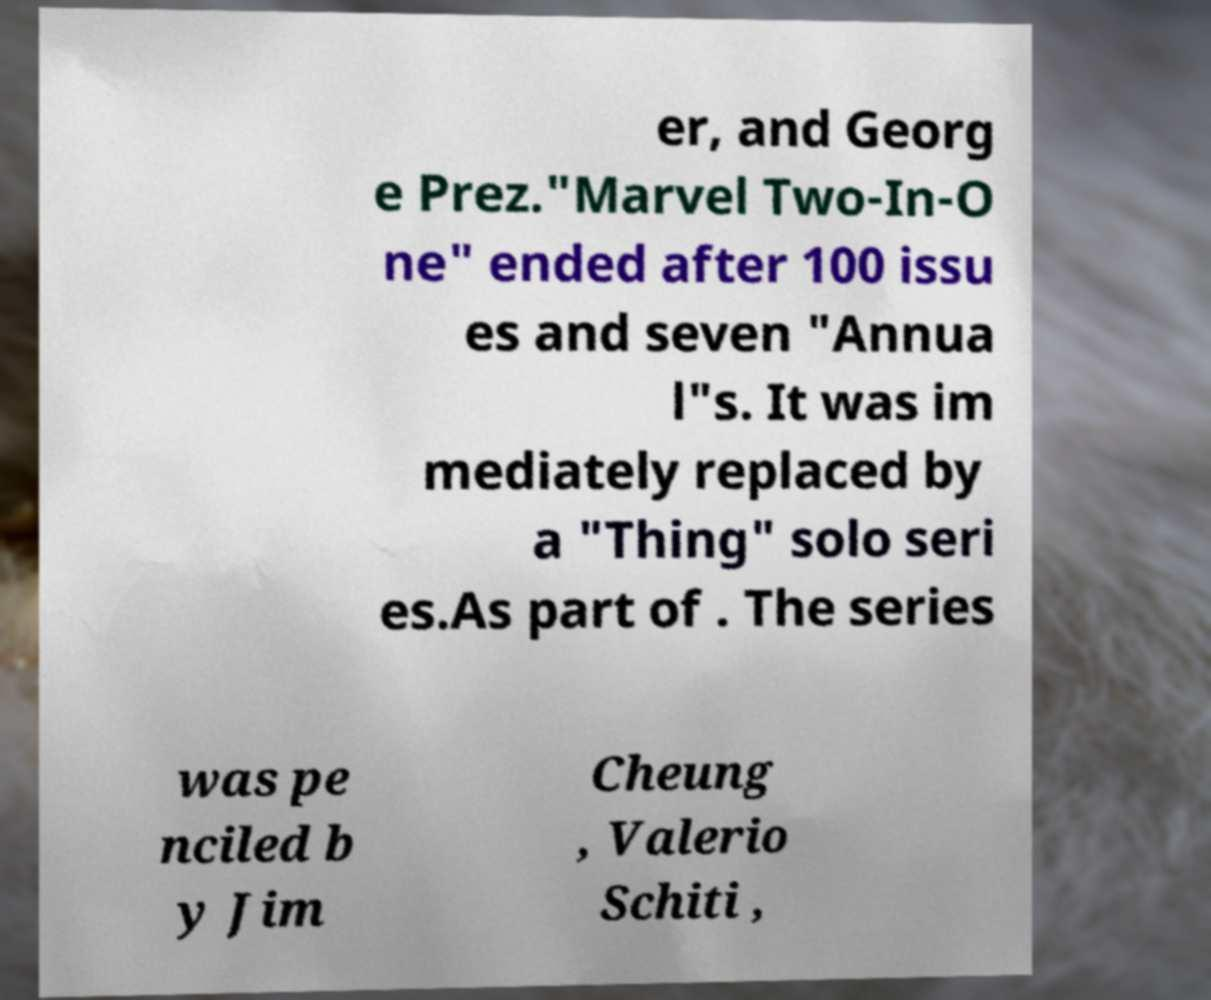Could you extract and type out the text from this image? er, and Georg e Prez."Marvel Two-In-O ne" ended after 100 issu es and seven "Annua l"s. It was im mediately replaced by a "Thing" solo seri es.As part of . The series was pe nciled b y Jim Cheung , Valerio Schiti , 